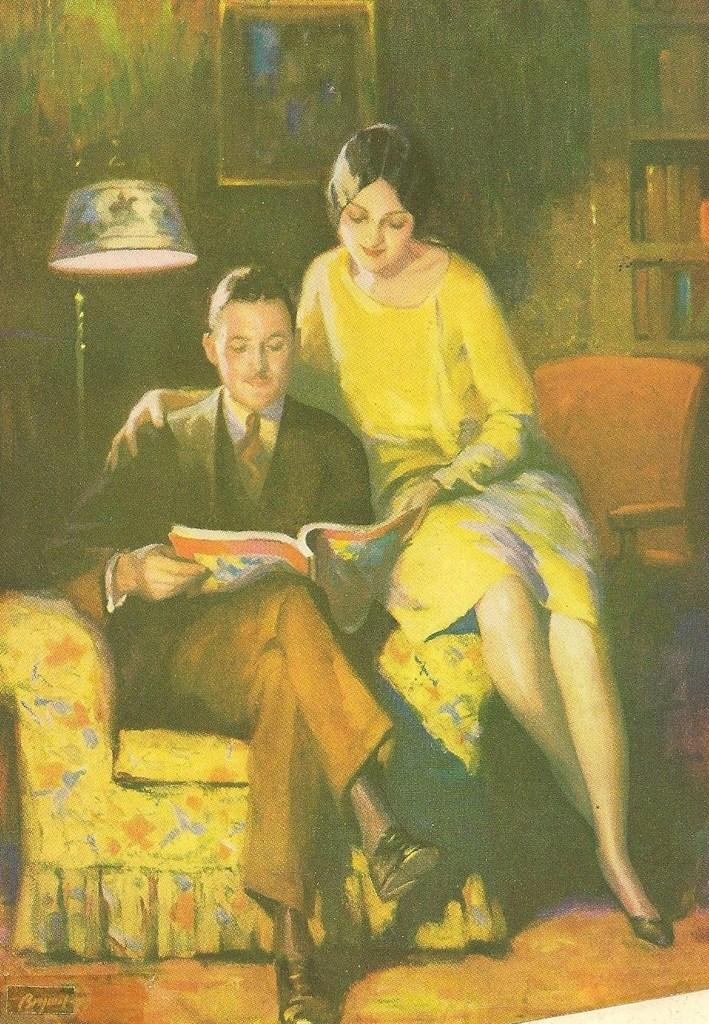What is the man in the image doing? The man is sitting on a chair in the image. What is the man holding in the image? The man is holding a book. Who is beside the man in the image? There is a woman beside the man in the image. What can be seen in the image that provides light? There is a lamp in the image. What type of furniture is present in the image that holds books? There are shelves with books in the image. What is hanging on the wall in the image? There is a frame on a wall in the image. What type of produce is being harvested in the image? There is no produce or harvesting activity present in the image. 